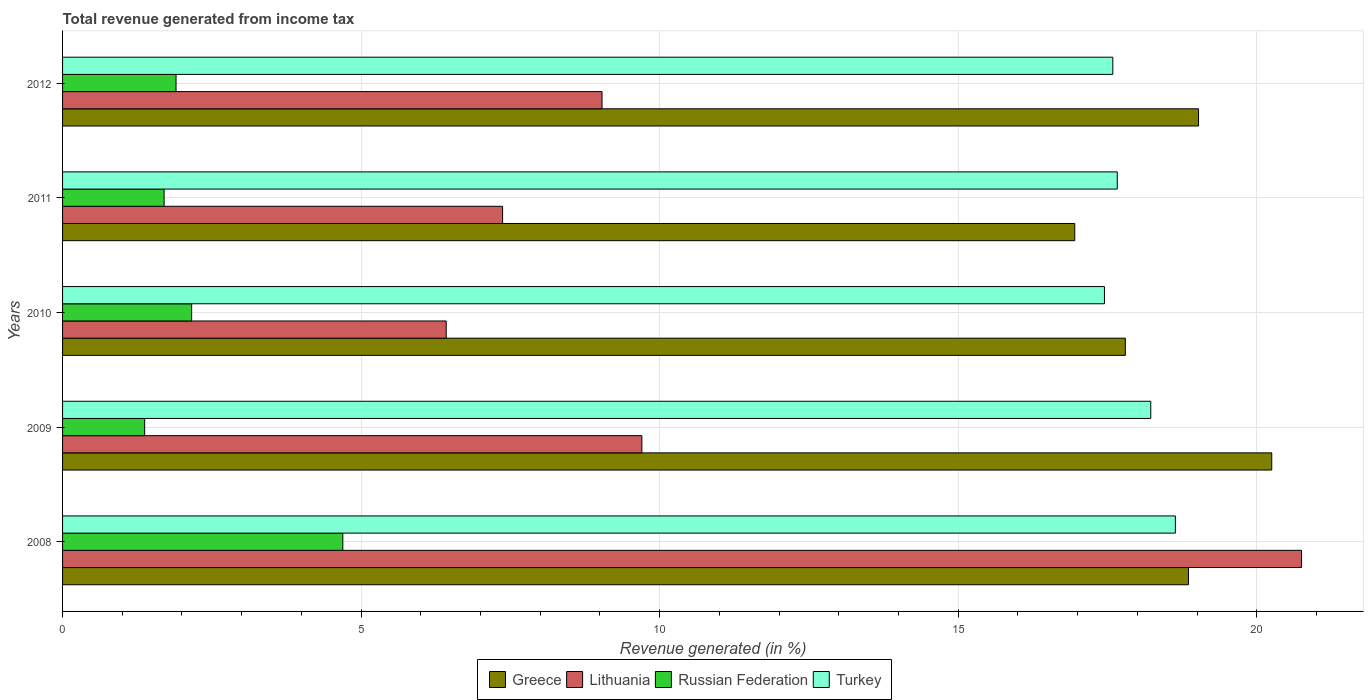How many different coloured bars are there?
Keep it short and to the point. 4. Are the number of bars on each tick of the Y-axis equal?
Offer a terse response. Yes. What is the total revenue generated in Greece in 2009?
Provide a short and direct response. 20.25. Across all years, what is the maximum total revenue generated in Greece?
Your answer should be compact. 20.25. Across all years, what is the minimum total revenue generated in Turkey?
Make the answer very short. 17.45. In which year was the total revenue generated in Lithuania maximum?
Make the answer very short. 2008. What is the total total revenue generated in Russian Federation in the graph?
Offer a terse response. 11.83. What is the difference between the total revenue generated in Greece in 2011 and that in 2012?
Provide a succinct answer. -2.07. What is the difference between the total revenue generated in Lithuania in 2011 and the total revenue generated in Russian Federation in 2008?
Your answer should be compact. 2.68. What is the average total revenue generated in Turkey per year?
Ensure brevity in your answer.  17.91. In the year 2008, what is the difference between the total revenue generated in Lithuania and total revenue generated in Greece?
Offer a very short reply. 1.89. What is the ratio of the total revenue generated in Lithuania in 2011 to that in 2012?
Offer a terse response. 0.82. What is the difference between the highest and the second highest total revenue generated in Lithuania?
Keep it short and to the point. 11.05. What is the difference between the highest and the lowest total revenue generated in Turkey?
Provide a short and direct response. 1.19. Is it the case that in every year, the sum of the total revenue generated in Greece and total revenue generated in Turkey is greater than the sum of total revenue generated in Russian Federation and total revenue generated in Lithuania?
Make the answer very short. No. What does the 2nd bar from the top in 2010 represents?
Keep it short and to the point. Russian Federation. What does the 1st bar from the bottom in 2009 represents?
Provide a succinct answer. Greece. What is the difference between two consecutive major ticks on the X-axis?
Keep it short and to the point. 5. Are the values on the major ticks of X-axis written in scientific E-notation?
Your response must be concise. No. How many legend labels are there?
Keep it short and to the point. 4. What is the title of the graph?
Make the answer very short. Total revenue generated from income tax. Does "East Asia (all income levels)" appear as one of the legend labels in the graph?
Your response must be concise. No. What is the label or title of the X-axis?
Offer a terse response. Revenue generated (in %). What is the label or title of the Y-axis?
Your answer should be very brief. Years. What is the Revenue generated (in %) in Greece in 2008?
Ensure brevity in your answer.  18.86. What is the Revenue generated (in %) in Lithuania in 2008?
Give a very brief answer. 20.75. What is the Revenue generated (in %) of Russian Federation in 2008?
Make the answer very short. 4.69. What is the Revenue generated (in %) of Turkey in 2008?
Your answer should be compact. 18.64. What is the Revenue generated (in %) of Greece in 2009?
Your response must be concise. 20.25. What is the Revenue generated (in %) of Lithuania in 2009?
Make the answer very short. 9.7. What is the Revenue generated (in %) in Russian Federation in 2009?
Your answer should be compact. 1.38. What is the Revenue generated (in %) of Turkey in 2009?
Give a very brief answer. 18.22. What is the Revenue generated (in %) in Greece in 2010?
Offer a terse response. 17.8. What is the Revenue generated (in %) of Lithuania in 2010?
Ensure brevity in your answer.  6.42. What is the Revenue generated (in %) of Russian Federation in 2010?
Your response must be concise. 2.16. What is the Revenue generated (in %) in Turkey in 2010?
Offer a very short reply. 17.45. What is the Revenue generated (in %) in Greece in 2011?
Give a very brief answer. 16.95. What is the Revenue generated (in %) in Lithuania in 2011?
Offer a terse response. 7.37. What is the Revenue generated (in %) of Russian Federation in 2011?
Your answer should be very brief. 1.7. What is the Revenue generated (in %) in Turkey in 2011?
Keep it short and to the point. 17.66. What is the Revenue generated (in %) in Greece in 2012?
Your answer should be very brief. 19.02. What is the Revenue generated (in %) in Lithuania in 2012?
Give a very brief answer. 9.03. What is the Revenue generated (in %) in Russian Federation in 2012?
Keep it short and to the point. 1.9. What is the Revenue generated (in %) of Turkey in 2012?
Give a very brief answer. 17.59. Across all years, what is the maximum Revenue generated (in %) in Greece?
Provide a succinct answer. 20.25. Across all years, what is the maximum Revenue generated (in %) in Lithuania?
Keep it short and to the point. 20.75. Across all years, what is the maximum Revenue generated (in %) of Russian Federation?
Keep it short and to the point. 4.69. Across all years, what is the maximum Revenue generated (in %) of Turkey?
Make the answer very short. 18.64. Across all years, what is the minimum Revenue generated (in %) in Greece?
Keep it short and to the point. 16.95. Across all years, what is the minimum Revenue generated (in %) in Lithuania?
Offer a very short reply. 6.42. Across all years, what is the minimum Revenue generated (in %) in Russian Federation?
Offer a terse response. 1.38. Across all years, what is the minimum Revenue generated (in %) of Turkey?
Provide a succinct answer. 17.45. What is the total Revenue generated (in %) in Greece in the graph?
Make the answer very short. 92.88. What is the total Revenue generated (in %) of Lithuania in the graph?
Your answer should be compact. 53.28. What is the total Revenue generated (in %) in Russian Federation in the graph?
Offer a very short reply. 11.83. What is the total Revenue generated (in %) in Turkey in the graph?
Make the answer very short. 89.56. What is the difference between the Revenue generated (in %) of Greece in 2008 and that in 2009?
Offer a very short reply. -1.39. What is the difference between the Revenue generated (in %) of Lithuania in 2008 and that in 2009?
Provide a short and direct response. 11.05. What is the difference between the Revenue generated (in %) of Russian Federation in 2008 and that in 2009?
Make the answer very short. 3.32. What is the difference between the Revenue generated (in %) of Turkey in 2008 and that in 2009?
Offer a terse response. 0.41. What is the difference between the Revenue generated (in %) in Greece in 2008 and that in 2010?
Your answer should be compact. 1.06. What is the difference between the Revenue generated (in %) in Lithuania in 2008 and that in 2010?
Ensure brevity in your answer.  14.32. What is the difference between the Revenue generated (in %) in Russian Federation in 2008 and that in 2010?
Make the answer very short. 2.53. What is the difference between the Revenue generated (in %) in Turkey in 2008 and that in 2010?
Keep it short and to the point. 1.19. What is the difference between the Revenue generated (in %) of Greece in 2008 and that in 2011?
Make the answer very short. 1.9. What is the difference between the Revenue generated (in %) of Lithuania in 2008 and that in 2011?
Your answer should be very brief. 13.38. What is the difference between the Revenue generated (in %) of Russian Federation in 2008 and that in 2011?
Provide a succinct answer. 2.99. What is the difference between the Revenue generated (in %) of Turkey in 2008 and that in 2011?
Your response must be concise. 0.97. What is the difference between the Revenue generated (in %) in Greece in 2008 and that in 2012?
Ensure brevity in your answer.  -0.17. What is the difference between the Revenue generated (in %) of Lithuania in 2008 and that in 2012?
Make the answer very short. 11.72. What is the difference between the Revenue generated (in %) in Russian Federation in 2008 and that in 2012?
Offer a terse response. 2.79. What is the difference between the Revenue generated (in %) of Turkey in 2008 and that in 2012?
Your answer should be compact. 1.05. What is the difference between the Revenue generated (in %) in Greece in 2009 and that in 2010?
Make the answer very short. 2.45. What is the difference between the Revenue generated (in %) of Lithuania in 2009 and that in 2010?
Ensure brevity in your answer.  3.28. What is the difference between the Revenue generated (in %) in Russian Federation in 2009 and that in 2010?
Offer a very short reply. -0.79. What is the difference between the Revenue generated (in %) in Turkey in 2009 and that in 2010?
Give a very brief answer. 0.78. What is the difference between the Revenue generated (in %) in Greece in 2009 and that in 2011?
Keep it short and to the point. 3.3. What is the difference between the Revenue generated (in %) of Lithuania in 2009 and that in 2011?
Give a very brief answer. 2.33. What is the difference between the Revenue generated (in %) of Russian Federation in 2009 and that in 2011?
Offer a very short reply. -0.33. What is the difference between the Revenue generated (in %) of Turkey in 2009 and that in 2011?
Your answer should be very brief. 0.56. What is the difference between the Revenue generated (in %) of Greece in 2009 and that in 2012?
Your answer should be very brief. 1.23. What is the difference between the Revenue generated (in %) of Lithuania in 2009 and that in 2012?
Ensure brevity in your answer.  0.67. What is the difference between the Revenue generated (in %) in Russian Federation in 2009 and that in 2012?
Make the answer very short. -0.53. What is the difference between the Revenue generated (in %) of Turkey in 2009 and that in 2012?
Give a very brief answer. 0.64. What is the difference between the Revenue generated (in %) of Greece in 2010 and that in 2011?
Give a very brief answer. 0.85. What is the difference between the Revenue generated (in %) in Lithuania in 2010 and that in 2011?
Make the answer very short. -0.94. What is the difference between the Revenue generated (in %) of Russian Federation in 2010 and that in 2011?
Your answer should be compact. 0.46. What is the difference between the Revenue generated (in %) in Turkey in 2010 and that in 2011?
Offer a very short reply. -0.21. What is the difference between the Revenue generated (in %) of Greece in 2010 and that in 2012?
Provide a succinct answer. -1.23. What is the difference between the Revenue generated (in %) in Lithuania in 2010 and that in 2012?
Provide a short and direct response. -2.61. What is the difference between the Revenue generated (in %) in Russian Federation in 2010 and that in 2012?
Offer a terse response. 0.26. What is the difference between the Revenue generated (in %) in Turkey in 2010 and that in 2012?
Your answer should be very brief. -0.14. What is the difference between the Revenue generated (in %) in Greece in 2011 and that in 2012?
Ensure brevity in your answer.  -2.07. What is the difference between the Revenue generated (in %) of Lithuania in 2011 and that in 2012?
Offer a very short reply. -1.67. What is the difference between the Revenue generated (in %) of Russian Federation in 2011 and that in 2012?
Offer a terse response. -0.2. What is the difference between the Revenue generated (in %) in Turkey in 2011 and that in 2012?
Offer a terse response. 0.07. What is the difference between the Revenue generated (in %) of Greece in 2008 and the Revenue generated (in %) of Lithuania in 2009?
Your answer should be very brief. 9.15. What is the difference between the Revenue generated (in %) of Greece in 2008 and the Revenue generated (in %) of Russian Federation in 2009?
Offer a very short reply. 17.48. What is the difference between the Revenue generated (in %) of Greece in 2008 and the Revenue generated (in %) of Turkey in 2009?
Your answer should be very brief. 0.63. What is the difference between the Revenue generated (in %) of Lithuania in 2008 and the Revenue generated (in %) of Russian Federation in 2009?
Offer a terse response. 19.37. What is the difference between the Revenue generated (in %) of Lithuania in 2008 and the Revenue generated (in %) of Turkey in 2009?
Provide a succinct answer. 2.52. What is the difference between the Revenue generated (in %) of Russian Federation in 2008 and the Revenue generated (in %) of Turkey in 2009?
Provide a short and direct response. -13.53. What is the difference between the Revenue generated (in %) in Greece in 2008 and the Revenue generated (in %) in Lithuania in 2010?
Offer a terse response. 12.43. What is the difference between the Revenue generated (in %) of Greece in 2008 and the Revenue generated (in %) of Russian Federation in 2010?
Ensure brevity in your answer.  16.69. What is the difference between the Revenue generated (in %) in Greece in 2008 and the Revenue generated (in %) in Turkey in 2010?
Offer a terse response. 1.41. What is the difference between the Revenue generated (in %) in Lithuania in 2008 and the Revenue generated (in %) in Russian Federation in 2010?
Offer a very short reply. 18.59. What is the difference between the Revenue generated (in %) in Lithuania in 2008 and the Revenue generated (in %) in Turkey in 2010?
Ensure brevity in your answer.  3.3. What is the difference between the Revenue generated (in %) in Russian Federation in 2008 and the Revenue generated (in %) in Turkey in 2010?
Your response must be concise. -12.76. What is the difference between the Revenue generated (in %) of Greece in 2008 and the Revenue generated (in %) of Lithuania in 2011?
Make the answer very short. 11.49. What is the difference between the Revenue generated (in %) of Greece in 2008 and the Revenue generated (in %) of Russian Federation in 2011?
Your answer should be compact. 17.16. What is the difference between the Revenue generated (in %) in Greece in 2008 and the Revenue generated (in %) in Turkey in 2011?
Make the answer very short. 1.19. What is the difference between the Revenue generated (in %) in Lithuania in 2008 and the Revenue generated (in %) in Russian Federation in 2011?
Provide a short and direct response. 19.05. What is the difference between the Revenue generated (in %) in Lithuania in 2008 and the Revenue generated (in %) in Turkey in 2011?
Ensure brevity in your answer.  3.09. What is the difference between the Revenue generated (in %) in Russian Federation in 2008 and the Revenue generated (in %) in Turkey in 2011?
Ensure brevity in your answer.  -12.97. What is the difference between the Revenue generated (in %) in Greece in 2008 and the Revenue generated (in %) in Lithuania in 2012?
Provide a short and direct response. 9.82. What is the difference between the Revenue generated (in %) of Greece in 2008 and the Revenue generated (in %) of Russian Federation in 2012?
Provide a succinct answer. 16.96. What is the difference between the Revenue generated (in %) of Greece in 2008 and the Revenue generated (in %) of Turkey in 2012?
Keep it short and to the point. 1.27. What is the difference between the Revenue generated (in %) in Lithuania in 2008 and the Revenue generated (in %) in Russian Federation in 2012?
Keep it short and to the point. 18.85. What is the difference between the Revenue generated (in %) of Lithuania in 2008 and the Revenue generated (in %) of Turkey in 2012?
Ensure brevity in your answer.  3.16. What is the difference between the Revenue generated (in %) in Russian Federation in 2008 and the Revenue generated (in %) in Turkey in 2012?
Keep it short and to the point. -12.9. What is the difference between the Revenue generated (in %) of Greece in 2009 and the Revenue generated (in %) of Lithuania in 2010?
Provide a succinct answer. 13.83. What is the difference between the Revenue generated (in %) in Greece in 2009 and the Revenue generated (in %) in Russian Federation in 2010?
Give a very brief answer. 18.09. What is the difference between the Revenue generated (in %) of Greece in 2009 and the Revenue generated (in %) of Turkey in 2010?
Provide a short and direct response. 2.8. What is the difference between the Revenue generated (in %) in Lithuania in 2009 and the Revenue generated (in %) in Russian Federation in 2010?
Give a very brief answer. 7.54. What is the difference between the Revenue generated (in %) of Lithuania in 2009 and the Revenue generated (in %) of Turkey in 2010?
Offer a terse response. -7.75. What is the difference between the Revenue generated (in %) of Russian Federation in 2009 and the Revenue generated (in %) of Turkey in 2010?
Make the answer very short. -16.07. What is the difference between the Revenue generated (in %) in Greece in 2009 and the Revenue generated (in %) in Lithuania in 2011?
Your answer should be very brief. 12.88. What is the difference between the Revenue generated (in %) of Greece in 2009 and the Revenue generated (in %) of Russian Federation in 2011?
Offer a terse response. 18.55. What is the difference between the Revenue generated (in %) of Greece in 2009 and the Revenue generated (in %) of Turkey in 2011?
Make the answer very short. 2.59. What is the difference between the Revenue generated (in %) in Lithuania in 2009 and the Revenue generated (in %) in Russian Federation in 2011?
Give a very brief answer. 8. What is the difference between the Revenue generated (in %) of Lithuania in 2009 and the Revenue generated (in %) of Turkey in 2011?
Your answer should be compact. -7.96. What is the difference between the Revenue generated (in %) in Russian Federation in 2009 and the Revenue generated (in %) in Turkey in 2011?
Provide a short and direct response. -16.29. What is the difference between the Revenue generated (in %) of Greece in 2009 and the Revenue generated (in %) of Lithuania in 2012?
Offer a very short reply. 11.22. What is the difference between the Revenue generated (in %) of Greece in 2009 and the Revenue generated (in %) of Russian Federation in 2012?
Your answer should be compact. 18.35. What is the difference between the Revenue generated (in %) in Greece in 2009 and the Revenue generated (in %) in Turkey in 2012?
Your answer should be compact. 2.66. What is the difference between the Revenue generated (in %) in Lithuania in 2009 and the Revenue generated (in %) in Russian Federation in 2012?
Your answer should be compact. 7.8. What is the difference between the Revenue generated (in %) of Lithuania in 2009 and the Revenue generated (in %) of Turkey in 2012?
Your answer should be very brief. -7.89. What is the difference between the Revenue generated (in %) in Russian Federation in 2009 and the Revenue generated (in %) in Turkey in 2012?
Provide a succinct answer. -16.21. What is the difference between the Revenue generated (in %) of Greece in 2010 and the Revenue generated (in %) of Lithuania in 2011?
Give a very brief answer. 10.43. What is the difference between the Revenue generated (in %) in Greece in 2010 and the Revenue generated (in %) in Russian Federation in 2011?
Make the answer very short. 16.1. What is the difference between the Revenue generated (in %) of Greece in 2010 and the Revenue generated (in %) of Turkey in 2011?
Your response must be concise. 0.14. What is the difference between the Revenue generated (in %) in Lithuania in 2010 and the Revenue generated (in %) in Russian Federation in 2011?
Your response must be concise. 4.72. What is the difference between the Revenue generated (in %) in Lithuania in 2010 and the Revenue generated (in %) in Turkey in 2011?
Ensure brevity in your answer.  -11.24. What is the difference between the Revenue generated (in %) in Russian Federation in 2010 and the Revenue generated (in %) in Turkey in 2011?
Make the answer very short. -15.5. What is the difference between the Revenue generated (in %) of Greece in 2010 and the Revenue generated (in %) of Lithuania in 2012?
Keep it short and to the point. 8.76. What is the difference between the Revenue generated (in %) in Greece in 2010 and the Revenue generated (in %) in Russian Federation in 2012?
Offer a very short reply. 15.9. What is the difference between the Revenue generated (in %) in Greece in 2010 and the Revenue generated (in %) in Turkey in 2012?
Provide a succinct answer. 0.21. What is the difference between the Revenue generated (in %) of Lithuania in 2010 and the Revenue generated (in %) of Russian Federation in 2012?
Your answer should be very brief. 4.52. What is the difference between the Revenue generated (in %) in Lithuania in 2010 and the Revenue generated (in %) in Turkey in 2012?
Ensure brevity in your answer.  -11.16. What is the difference between the Revenue generated (in %) in Russian Federation in 2010 and the Revenue generated (in %) in Turkey in 2012?
Provide a short and direct response. -15.43. What is the difference between the Revenue generated (in %) in Greece in 2011 and the Revenue generated (in %) in Lithuania in 2012?
Give a very brief answer. 7.92. What is the difference between the Revenue generated (in %) in Greece in 2011 and the Revenue generated (in %) in Russian Federation in 2012?
Your response must be concise. 15.05. What is the difference between the Revenue generated (in %) in Greece in 2011 and the Revenue generated (in %) in Turkey in 2012?
Keep it short and to the point. -0.64. What is the difference between the Revenue generated (in %) in Lithuania in 2011 and the Revenue generated (in %) in Russian Federation in 2012?
Provide a short and direct response. 5.47. What is the difference between the Revenue generated (in %) in Lithuania in 2011 and the Revenue generated (in %) in Turkey in 2012?
Keep it short and to the point. -10.22. What is the difference between the Revenue generated (in %) in Russian Federation in 2011 and the Revenue generated (in %) in Turkey in 2012?
Keep it short and to the point. -15.89. What is the average Revenue generated (in %) in Greece per year?
Keep it short and to the point. 18.58. What is the average Revenue generated (in %) of Lithuania per year?
Keep it short and to the point. 10.66. What is the average Revenue generated (in %) in Russian Federation per year?
Your response must be concise. 2.37. What is the average Revenue generated (in %) in Turkey per year?
Your answer should be very brief. 17.91. In the year 2008, what is the difference between the Revenue generated (in %) of Greece and Revenue generated (in %) of Lithuania?
Your answer should be compact. -1.89. In the year 2008, what is the difference between the Revenue generated (in %) in Greece and Revenue generated (in %) in Russian Federation?
Offer a terse response. 14.16. In the year 2008, what is the difference between the Revenue generated (in %) of Greece and Revenue generated (in %) of Turkey?
Provide a succinct answer. 0.22. In the year 2008, what is the difference between the Revenue generated (in %) in Lithuania and Revenue generated (in %) in Russian Federation?
Your answer should be compact. 16.06. In the year 2008, what is the difference between the Revenue generated (in %) of Lithuania and Revenue generated (in %) of Turkey?
Your response must be concise. 2.11. In the year 2008, what is the difference between the Revenue generated (in %) in Russian Federation and Revenue generated (in %) in Turkey?
Offer a terse response. -13.94. In the year 2009, what is the difference between the Revenue generated (in %) in Greece and Revenue generated (in %) in Lithuania?
Offer a very short reply. 10.55. In the year 2009, what is the difference between the Revenue generated (in %) of Greece and Revenue generated (in %) of Russian Federation?
Keep it short and to the point. 18.88. In the year 2009, what is the difference between the Revenue generated (in %) in Greece and Revenue generated (in %) in Turkey?
Your answer should be compact. 2.03. In the year 2009, what is the difference between the Revenue generated (in %) in Lithuania and Revenue generated (in %) in Russian Federation?
Ensure brevity in your answer.  8.33. In the year 2009, what is the difference between the Revenue generated (in %) in Lithuania and Revenue generated (in %) in Turkey?
Offer a very short reply. -8.52. In the year 2009, what is the difference between the Revenue generated (in %) in Russian Federation and Revenue generated (in %) in Turkey?
Provide a short and direct response. -16.85. In the year 2010, what is the difference between the Revenue generated (in %) of Greece and Revenue generated (in %) of Lithuania?
Offer a very short reply. 11.37. In the year 2010, what is the difference between the Revenue generated (in %) of Greece and Revenue generated (in %) of Russian Federation?
Offer a very short reply. 15.64. In the year 2010, what is the difference between the Revenue generated (in %) in Greece and Revenue generated (in %) in Turkey?
Your response must be concise. 0.35. In the year 2010, what is the difference between the Revenue generated (in %) in Lithuania and Revenue generated (in %) in Russian Federation?
Provide a short and direct response. 4.26. In the year 2010, what is the difference between the Revenue generated (in %) in Lithuania and Revenue generated (in %) in Turkey?
Offer a terse response. -11.02. In the year 2010, what is the difference between the Revenue generated (in %) of Russian Federation and Revenue generated (in %) of Turkey?
Keep it short and to the point. -15.29. In the year 2011, what is the difference between the Revenue generated (in %) of Greece and Revenue generated (in %) of Lithuania?
Offer a terse response. 9.58. In the year 2011, what is the difference between the Revenue generated (in %) in Greece and Revenue generated (in %) in Russian Federation?
Give a very brief answer. 15.25. In the year 2011, what is the difference between the Revenue generated (in %) in Greece and Revenue generated (in %) in Turkey?
Your response must be concise. -0.71. In the year 2011, what is the difference between the Revenue generated (in %) of Lithuania and Revenue generated (in %) of Russian Federation?
Offer a very short reply. 5.67. In the year 2011, what is the difference between the Revenue generated (in %) of Lithuania and Revenue generated (in %) of Turkey?
Your answer should be very brief. -10.29. In the year 2011, what is the difference between the Revenue generated (in %) of Russian Federation and Revenue generated (in %) of Turkey?
Give a very brief answer. -15.96. In the year 2012, what is the difference between the Revenue generated (in %) of Greece and Revenue generated (in %) of Lithuania?
Give a very brief answer. 9.99. In the year 2012, what is the difference between the Revenue generated (in %) in Greece and Revenue generated (in %) in Russian Federation?
Make the answer very short. 17.12. In the year 2012, what is the difference between the Revenue generated (in %) in Greece and Revenue generated (in %) in Turkey?
Provide a short and direct response. 1.44. In the year 2012, what is the difference between the Revenue generated (in %) in Lithuania and Revenue generated (in %) in Russian Federation?
Give a very brief answer. 7.13. In the year 2012, what is the difference between the Revenue generated (in %) in Lithuania and Revenue generated (in %) in Turkey?
Provide a short and direct response. -8.55. In the year 2012, what is the difference between the Revenue generated (in %) of Russian Federation and Revenue generated (in %) of Turkey?
Provide a short and direct response. -15.69. What is the ratio of the Revenue generated (in %) of Greece in 2008 to that in 2009?
Give a very brief answer. 0.93. What is the ratio of the Revenue generated (in %) in Lithuania in 2008 to that in 2009?
Your response must be concise. 2.14. What is the ratio of the Revenue generated (in %) of Russian Federation in 2008 to that in 2009?
Ensure brevity in your answer.  3.41. What is the ratio of the Revenue generated (in %) in Turkey in 2008 to that in 2009?
Provide a short and direct response. 1.02. What is the ratio of the Revenue generated (in %) in Greece in 2008 to that in 2010?
Your response must be concise. 1.06. What is the ratio of the Revenue generated (in %) of Lithuania in 2008 to that in 2010?
Keep it short and to the point. 3.23. What is the ratio of the Revenue generated (in %) in Russian Federation in 2008 to that in 2010?
Your response must be concise. 2.17. What is the ratio of the Revenue generated (in %) of Turkey in 2008 to that in 2010?
Your response must be concise. 1.07. What is the ratio of the Revenue generated (in %) in Greece in 2008 to that in 2011?
Your answer should be very brief. 1.11. What is the ratio of the Revenue generated (in %) of Lithuania in 2008 to that in 2011?
Offer a terse response. 2.82. What is the ratio of the Revenue generated (in %) of Russian Federation in 2008 to that in 2011?
Keep it short and to the point. 2.76. What is the ratio of the Revenue generated (in %) in Turkey in 2008 to that in 2011?
Offer a very short reply. 1.06. What is the ratio of the Revenue generated (in %) of Greece in 2008 to that in 2012?
Your response must be concise. 0.99. What is the ratio of the Revenue generated (in %) in Lithuania in 2008 to that in 2012?
Your answer should be compact. 2.3. What is the ratio of the Revenue generated (in %) in Russian Federation in 2008 to that in 2012?
Your response must be concise. 2.47. What is the ratio of the Revenue generated (in %) of Turkey in 2008 to that in 2012?
Make the answer very short. 1.06. What is the ratio of the Revenue generated (in %) in Greece in 2009 to that in 2010?
Offer a very short reply. 1.14. What is the ratio of the Revenue generated (in %) in Lithuania in 2009 to that in 2010?
Make the answer very short. 1.51. What is the ratio of the Revenue generated (in %) in Russian Federation in 2009 to that in 2010?
Provide a short and direct response. 0.64. What is the ratio of the Revenue generated (in %) of Turkey in 2009 to that in 2010?
Your answer should be compact. 1.04. What is the ratio of the Revenue generated (in %) in Greece in 2009 to that in 2011?
Offer a very short reply. 1.19. What is the ratio of the Revenue generated (in %) of Lithuania in 2009 to that in 2011?
Your response must be concise. 1.32. What is the ratio of the Revenue generated (in %) of Russian Federation in 2009 to that in 2011?
Your answer should be very brief. 0.81. What is the ratio of the Revenue generated (in %) in Turkey in 2009 to that in 2011?
Your answer should be very brief. 1.03. What is the ratio of the Revenue generated (in %) in Greece in 2009 to that in 2012?
Offer a terse response. 1.06. What is the ratio of the Revenue generated (in %) of Lithuania in 2009 to that in 2012?
Provide a succinct answer. 1.07. What is the ratio of the Revenue generated (in %) of Russian Federation in 2009 to that in 2012?
Your answer should be compact. 0.72. What is the ratio of the Revenue generated (in %) of Turkey in 2009 to that in 2012?
Your response must be concise. 1.04. What is the ratio of the Revenue generated (in %) of Greece in 2010 to that in 2011?
Offer a very short reply. 1.05. What is the ratio of the Revenue generated (in %) of Lithuania in 2010 to that in 2011?
Provide a succinct answer. 0.87. What is the ratio of the Revenue generated (in %) of Russian Federation in 2010 to that in 2011?
Your answer should be compact. 1.27. What is the ratio of the Revenue generated (in %) of Turkey in 2010 to that in 2011?
Your answer should be very brief. 0.99. What is the ratio of the Revenue generated (in %) of Greece in 2010 to that in 2012?
Your answer should be very brief. 0.94. What is the ratio of the Revenue generated (in %) of Lithuania in 2010 to that in 2012?
Your answer should be very brief. 0.71. What is the ratio of the Revenue generated (in %) of Russian Federation in 2010 to that in 2012?
Your answer should be compact. 1.14. What is the ratio of the Revenue generated (in %) of Turkey in 2010 to that in 2012?
Provide a succinct answer. 0.99. What is the ratio of the Revenue generated (in %) in Greece in 2011 to that in 2012?
Keep it short and to the point. 0.89. What is the ratio of the Revenue generated (in %) in Lithuania in 2011 to that in 2012?
Provide a succinct answer. 0.82. What is the ratio of the Revenue generated (in %) of Russian Federation in 2011 to that in 2012?
Your answer should be very brief. 0.89. What is the ratio of the Revenue generated (in %) of Turkey in 2011 to that in 2012?
Provide a succinct answer. 1. What is the difference between the highest and the second highest Revenue generated (in %) in Greece?
Make the answer very short. 1.23. What is the difference between the highest and the second highest Revenue generated (in %) of Lithuania?
Provide a short and direct response. 11.05. What is the difference between the highest and the second highest Revenue generated (in %) in Russian Federation?
Your response must be concise. 2.53. What is the difference between the highest and the second highest Revenue generated (in %) of Turkey?
Provide a short and direct response. 0.41. What is the difference between the highest and the lowest Revenue generated (in %) in Greece?
Offer a very short reply. 3.3. What is the difference between the highest and the lowest Revenue generated (in %) of Lithuania?
Give a very brief answer. 14.32. What is the difference between the highest and the lowest Revenue generated (in %) of Russian Federation?
Offer a terse response. 3.32. What is the difference between the highest and the lowest Revenue generated (in %) of Turkey?
Ensure brevity in your answer.  1.19. 